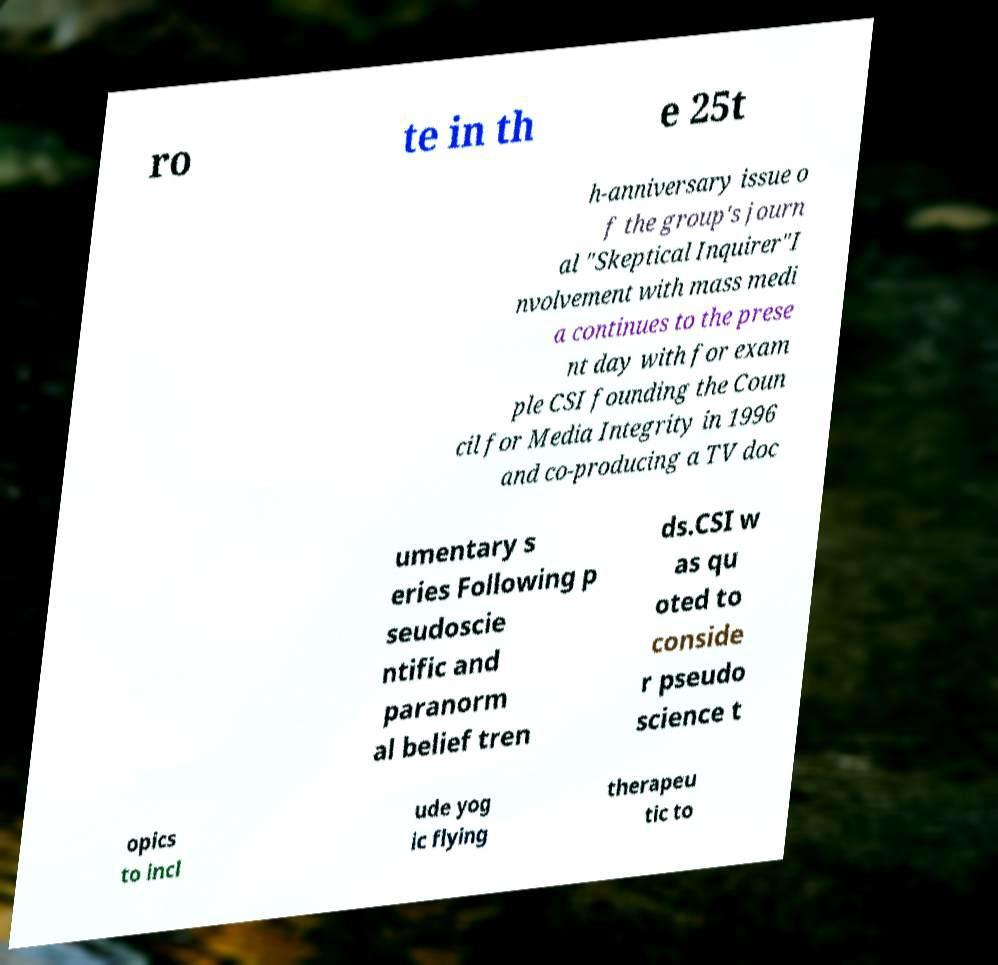Could you extract and type out the text from this image? ro te in th e 25t h-anniversary issue o f the group's journ al "Skeptical Inquirer"I nvolvement with mass medi a continues to the prese nt day with for exam ple CSI founding the Coun cil for Media Integrity in 1996 and co-producing a TV doc umentary s eries Following p seudoscie ntific and paranorm al belief tren ds.CSI w as qu oted to conside r pseudo science t opics to incl ude yog ic flying therapeu tic to 